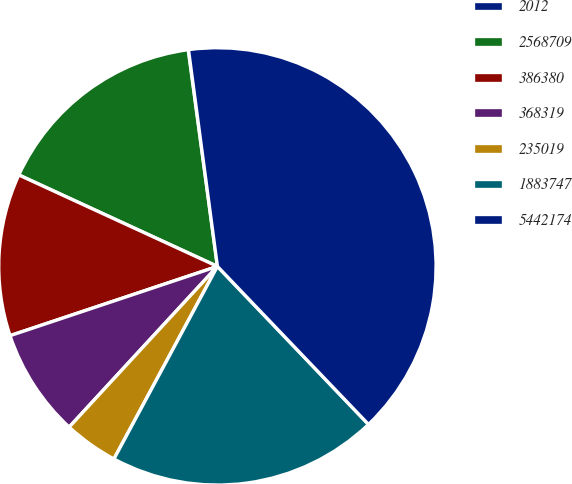Convert chart to OTSL. <chart><loc_0><loc_0><loc_500><loc_500><pie_chart><fcel>2012<fcel>2568709<fcel>386380<fcel>368319<fcel>235019<fcel>1883747<fcel>5442174<nl><fcel>0.02%<fcel>16.0%<fcel>12.0%<fcel>8.01%<fcel>4.01%<fcel>19.99%<fcel>39.97%<nl></chart> 